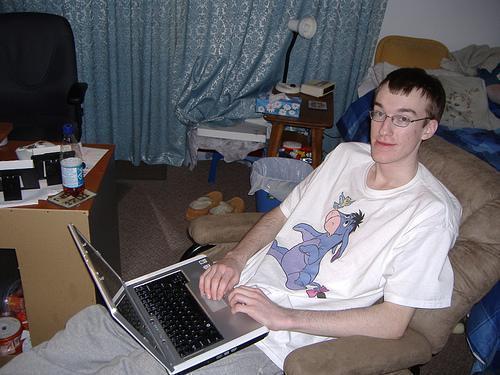What is the can to his side primarily used for?
Answer the question by selecting the correct answer among the 4 following choices and explain your choice with a short sentence. The answer should be formatted with the following format: `Answer: choice
Rationale: rationale.`
Options: Soda, trash, cookies, money. Answer: trash.
Rationale: There is a trash can to the left of the man in the armchair. Which children's author's creation does this man show off?
Choose the right answer from the provided options to respond to the question.
Options: Stephen king, sendak, disney, aa milne. Aa milne. 